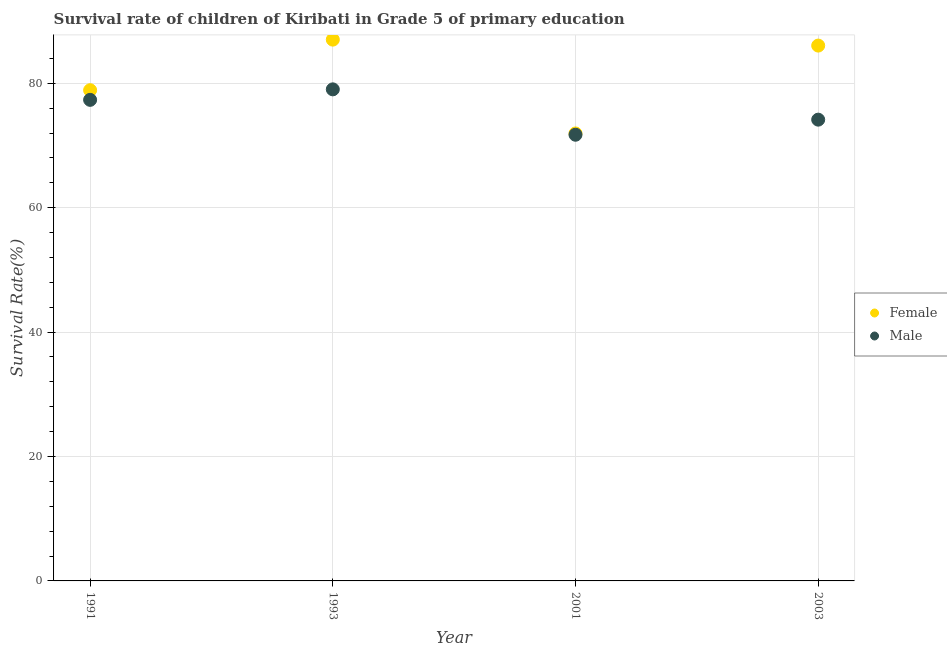Is the number of dotlines equal to the number of legend labels?
Your answer should be very brief. Yes. What is the survival rate of male students in primary education in 2001?
Offer a very short reply. 71.73. Across all years, what is the maximum survival rate of male students in primary education?
Your answer should be compact. 79.03. Across all years, what is the minimum survival rate of female students in primary education?
Keep it short and to the point. 71.94. In which year was the survival rate of male students in primary education maximum?
Provide a short and direct response. 1993. In which year was the survival rate of male students in primary education minimum?
Offer a terse response. 2001. What is the total survival rate of female students in primary education in the graph?
Offer a very short reply. 323.92. What is the difference between the survival rate of male students in primary education in 1991 and that in 1993?
Keep it short and to the point. -1.69. What is the difference between the survival rate of male students in primary education in 1993 and the survival rate of female students in primary education in 1991?
Your response must be concise. 0.13. What is the average survival rate of male students in primary education per year?
Give a very brief answer. 75.56. In the year 2001, what is the difference between the survival rate of female students in primary education and survival rate of male students in primary education?
Your answer should be very brief. 0.21. What is the ratio of the survival rate of female students in primary education in 1993 to that in 2003?
Keep it short and to the point. 1.01. What is the difference between the highest and the second highest survival rate of female students in primary education?
Provide a short and direct response. 0.96. What is the difference between the highest and the lowest survival rate of male students in primary education?
Offer a very short reply. 7.3. In how many years, is the survival rate of male students in primary education greater than the average survival rate of male students in primary education taken over all years?
Offer a very short reply. 2. Is the survival rate of female students in primary education strictly greater than the survival rate of male students in primary education over the years?
Offer a terse response. Yes. How many dotlines are there?
Keep it short and to the point. 2. Does the graph contain any zero values?
Your response must be concise. No. Does the graph contain grids?
Ensure brevity in your answer.  Yes. Where does the legend appear in the graph?
Offer a very short reply. Center right. How many legend labels are there?
Your answer should be very brief. 2. What is the title of the graph?
Offer a terse response. Survival rate of children of Kiribati in Grade 5 of primary education. Does "Secondary" appear as one of the legend labels in the graph?
Provide a short and direct response. No. What is the label or title of the X-axis?
Give a very brief answer. Year. What is the label or title of the Y-axis?
Your answer should be compact. Survival Rate(%). What is the Survival Rate(%) of Female in 1991?
Give a very brief answer. 78.89. What is the Survival Rate(%) in Male in 1991?
Give a very brief answer. 77.34. What is the Survival Rate(%) in Female in 1993?
Offer a very short reply. 87.02. What is the Survival Rate(%) of Male in 1993?
Keep it short and to the point. 79.03. What is the Survival Rate(%) of Female in 2001?
Keep it short and to the point. 71.94. What is the Survival Rate(%) of Male in 2001?
Your answer should be compact. 71.73. What is the Survival Rate(%) in Female in 2003?
Your answer should be compact. 86.07. What is the Survival Rate(%) of Male in 2003?
Give a very brief answer. 74.16. Across all years, what is the maximum Survival Rate(%) of Female?
Make the answer very short. 87.02. Across all years, what is the maximum Survival Rate(%) in Male?
Your answer should be compact. 79.03. Across all years, what is the minimum Survival Rate(%) in Female?
Your answer should be very brief. 71.94. Across all years, what is the minimum Survival Rate(%) in Male?
Keep it short and to the point. 71.73. What is the total Survival Rate(%) of Female in the graph?
Offer a very short reply. 323.92. What is the total Survival Rate(%) in Male in the graph?
Offer a terse response. 302.25. What is the difference between the Survival Rate(%) in Female in 1991 and that in 1993?
Your answer should be compact. -8.13. What is the difference between the Survival Rate(%) in Male in 1991 and that in 1993?
Make the answer very short. -1.69. What is the difference between the Survival Rate(%) of Female in 1991 and that in 2001?
Your response must be concise. 6.95. What is the difference between the Survival Rate(%) of Male in 1991 and that in 2001?
Give a very brief answer. 5.61. What is the difference between the Survival Rate(%) of Female in 1991 and that in 2003?
Make the answer very short. -7.17. What is the difference between the Survival Rate(%) in Male in 1991 and that in 2003?
Offer a very short reply. 3.18. What is the difference between the Survival Rate(%) in Female in 1993 and that in 2001?
Ensure brevity in your answer.  15.08. What is the difference between the Survival Rate(%) of Male in 1993 and that in 2001?
Give a very brief answer. 7.3. What is the difference between the Survival Rate(%) in Female in 1993 and that in 2003?
Your response must be concise. 0.96. What is the difference between the Survival Rate(%) of Male in 1993 and that in 2003?
Offer a terse response. 4.87. What is the difference between the Survival Rate(%) of Female in 2001 and that in 2003?
Offer a terse response. -14.13. What is the difference between the Survival Rate(%) of Male in 2001 and that in 2003?
Make the answer very short. -2.43. What is the difference between the Survival Rate(%) in Female in 1991 and the Survival Rate(%) in Male in 1993?
Your answer should be very brief. -0.13. What is the difference between the Survival Rate(%) in Female in 1991 and the Survival Rate(%) in Male in 2001?
Your answer should be very brief. 7.16. What is the difference between the Survival Rate(%) of Female in 1991 and the Survival Rate(%) of Male in 2003?
Your answer should be very brief. 4.74. What is the difference between the Survival Rate(%) of Female in 1993 and the Survival Rate(%) of Male in 2001?
Offer a very short reply. 15.29. What is the difference between the Survival Rate(%) in Female in 1993 and the Survival Rate(%) in Male in 2003?
Offer a very short reply. 12.86. What is the difference between the Survival Rate(%) in Female in 2001 and the Survival Rate(%) in Male in 2003?
Your answer should be very brief. -2.22. What is the average Survival Rate(%) of Female per year?
Offer a terse response. 80.98. What is the average Survival Rate(%) in Male per year?
Offer a very short reply. 75.56. In the year 1991, what is the difference between the Survival Rate(%) of Female and Survival Rate(%) of Male?
Offer a very short reply. 1.55. In the year 1993, what is the difference between the Survival Rate(%) in Female and Survival Rate(%) in Male?
Make the answer very short. 7.99. In the year 2001, what is the difference between the Survival Rate(%) in Female and Survival Rate(%) in Male?
Provide a short and direct response. 0.21. In the year 2003, what is the difference between the Survival Rate(%) of Female and Survival Rate(%) of Male?
Your response must be concise. 11.91. What is the ratio of the Survival Rate(%) in Female in 1991 to that in 1993?
Provide a short and direct response. 0.91. What is the ratio of the Survival Rate(%) in Male in 1991 to that in 1993?
Provide a succinct answer. 0.98. What is the ratio of the Survival Rate(%) in Female in 1991 to that in 2001?
Offer a very short reply. 1.1. What is the ratio of the Survival Rate(%) of Male in 1991 to that in 2001?
Provide a short and direct response. 1.08. What is the ratio of the Survival Rate(%) of Female in 1991 to that in 2003?
Your answer should be compact. 0.92. What is the ratio of the Survival Rate(%) in Male in 1991 to that in 2003?
Your answer should be very brief. 1.04. What is the ratio of the Survival Rate(%) in Female in 1993 to that in 2001?
Provide a short and direct response. 1.21. What is the ratio of the Survival Rate(%) of Male in 1993 to that in 2001?
Give a very brief answer. 1.1. What is the ratio of the Survival Rate(%) of Female in 1993 to that in 2003?
Your answer should be compact. 1.01. What is the ratio of the Survival Rate(%) in Male in 1993 to that in 2003?
Provide a succinct answer. 1.07. What is the ratio of the Survival Rate(%) of Female in 2001 to that in 2003?
Provide a short and direct response. 0.84. What is the ratio of the Survival Rate(%) of Male in 2001 to that in 2003?
Ensure brevity in your answer.  0.97. What is the difference between the highest and the second highest Survival Rate(%) of Female?
Your answer should be very brief. 0.96. What is the difference between the highest and the second highest Survival Rate(%) of Male?
Offer a very short reply. 1.69. What is the difference between the highest and the lowest Survival Rate(%) of Female?
Give a very brief answer. 15.08. What is the difference between the highest and the lowest Survival Rate(%) of Male?
Ensure brevity in your answer.  7.3. 